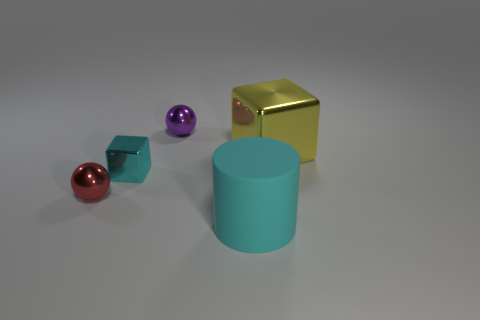Add 2 purple metal objects. How many objects exist? 7 Subtract all blocks. How many objects are left? 3 Add 4 shiny cubes. How many shiny cubes are left? 6 Add 2 tiny red things. How many tiny red things exist? 3 Subtract 0 yellow spheres. How many objects are left? 5 Subtract all tiny brown shiny spheres. Subtract all small purple spheres. How many objects are left? 4 